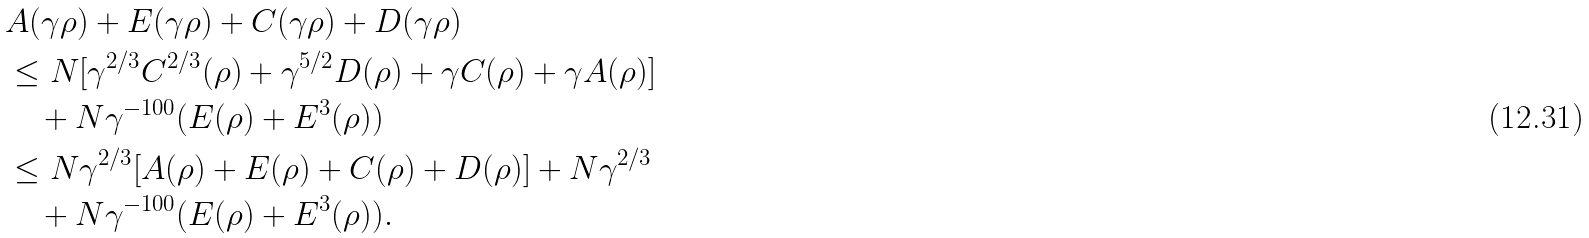<formula> <loc_0><loc_0><loc_500><loc_500>& A ( \gamma \rho ) + E ( \gamma \rho ) + C ( \gamma \rho ) + D ( \gamma \rho ) \\ & \leq N [ \gamma ^ { 2 / 3 } C ^ { 2 / 3 } ( \rho ) + \gamma ^ { 5 / 2 } D ( \rho ) + \gamma C ( \rho ) + \gamma A ( \rho ) ] \\ & \quad + N \gamma ^ { - 1 0 0 } ( E ( \rho ) + E ^ { 3 } ( \rho ) ) \\ & \leq N \gamma ^ { 2 / 3 } [ A ( \rho ) + E ( \rho ) + C ( \rho ) + D ( \rho ) ] + N \gamma ^ { 2 / 3 } \\ & \quad + N \gamma ^ { - 1 0 0 } ( E ( \rho ) + E ^ { 3 } ( \rho ) ) .</formula> 